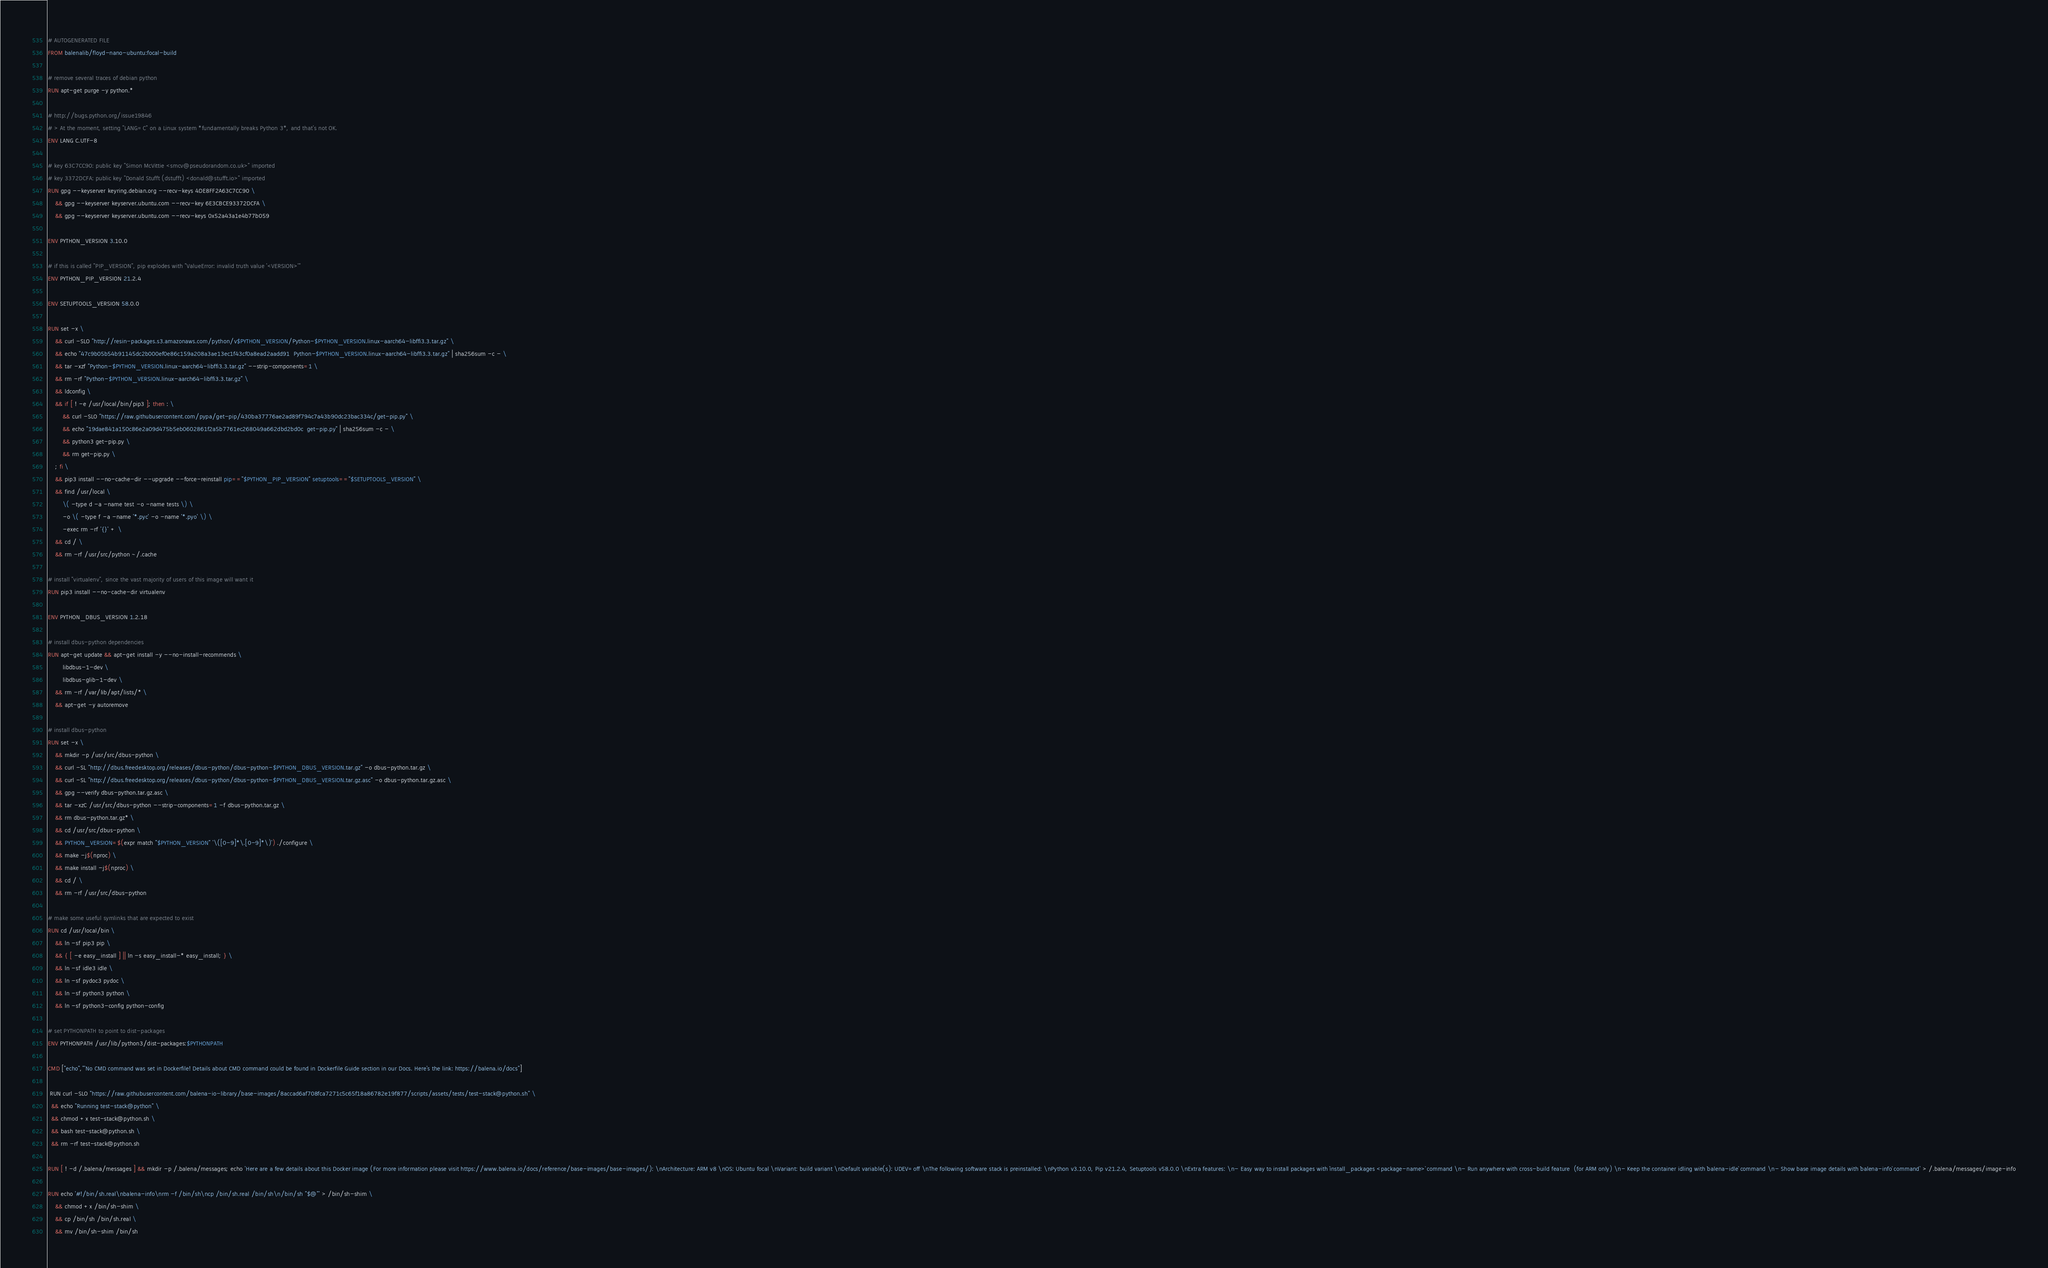<code> <loc_0><loc_0><loc_500><loc_500><_Dockerfile_># AUTOGENERATED FILE
FROM balenalib/floyd-nano-ubuntu:focal-build

# remove several traces of debian python
RUN apt-get purge -y python.*

# http://bugs.python.org/issue19846
# > At the moment, setting "LANG=C" on a Linux system *fundamentally breaks Python 3*, and that's not OK.
ENV LANG C.UTF-8

# key 63C7CC90: public key "Simon McVittie <smcv@pseudorandom.co.uk>" imported
# key 3372DCFA: public key "Donald Stufft (dstufft) <donald@stufft.io>" imported
RUN gpg --keyserver keyring.debian.org --recv-keys 4DE8FF2A63C7CC90 \
	&& gpg --keyserver keyserver.ubuntu.com --recv-key 6E3CBCE93372DCFA \
	&& gpg --keyserver keyserver.ubuntu.com --recv-keys 0x52a43a1e4b77b059

ENV PYTHON_VERSION 3.10.0

# if this is called "PIP_VERSION", pip explodes with "ValueError: invalid truth value '<VERSION>'"
ENV PYTHON_PIP_VERSION 21.2.4

ENV SETUPTOOLS_VERSION 58.0.0

RUN set -x \
	&& curl -SLO "http://resin-packages.s3.amazonaws.com/python/v$PYTHON_VERSION/Python-$PYTHON_VERSION.linux-aarch64-libffi3.3.tar.gz" \
	&& echo "47c9b05b54b91145dc2b000ef0e86c159a208a3ae13ec1f43cf0a8ead2aadd91  Python-$PYTHON_VERSION.linux-aarch64-libffi3.3.tar.gz" | sha256sum -c - \
	&& tar -xzf "Python-$PYTHON_VERSION.linux-aarch64-libffi3.3.tar.gz" --strip-components=1 \
	&& rm -rf "Python-$PYTHON_VERSION.linux-aarch64-libffi3.3.tar.gz" \
	&& ldconfig \
	&& if [ ! -e /usr/local/bin/pip3 ]; then : \
		&& curl -SLO "https://raw.githubusercontent.com/pypa/get-pip/430ba37776ae2ad89f794c7a43b90dc23bac334c/get-pip.py" \
		&& echo "19dae841a150c86e2a09d475b5eb0602861f2a5b7761ec268049a662dbd2bd0c  get-pip.py" | sha256sum -c - \
		&& python3 get-pip.py \
		&& rm get-pip.py \
	; fi \
	&& pip3 install --no-cache-dir --upgrade --force-reinstall pip=="$PYTHON_PIP_VERSION" setuptools=="$SETUPTOOLS_VERSION" \
	&& find /usr/local \
		\( -type d -a -name test -o -name tests \) \
		-o \( -type f -a -name '*.pyc' -o -name '*.pyo' \) \
		-exec rm -rf '{}' + \
	&& cd / \
	&& rm -rf /usr/src/python ~/.cache

# install "virtualenv", since the vast majority of users of this image will want it
RUN pip3 install --no-cache-dir virtualenv

ENV PYTHON_DBUS_VERSION 1.2.18

# install dbus-python dependencies 
RUN apt-get update && apt-get install -y --no-install-recommends \
		libdbus-1-dev \
		libdbus-glib-1-dev \
	&& rm -rf /var/lib/apt/lists/* \
	&& apt-get -y autoremove

# install dbus-python
RUN set -x \
	&& mkdir -p /usr/src/dbus-python \
	&& curl -SL "http://dbus.freedesktop.org/releases/dbus-python/dbus-python-$PYTHON_DBUS_VERSION.tar.gz" -o dbus-python.tar.gz \
	&& curl -SL "http://dbus.freedesktop.org/releases/dbus-python/dbus-python-$PYTHON_DBUS_VERSION.tar.gz.asc" -o dbus-python.tar.gz.asc \
	&& gpg --verify dbus-python.tar.gz.asc \
	&& tar -xzC /usr/src/dbus-python --strip-components=1 -f dbus-python.tar.gz \
	&& rm dbus-python.tar.gz* \
	&& cd /usr/src/dbus-python \
	&& PYTHON_VERSION=$(expr match "$PYTHON_VERSION" '\([0-9]*\.[0-9]*\)') ./configure \
	&& make -j$(nproc) \
	&& make install -j$(nproc) \
	&& cd / \
	&& rm -rf /usr/src/dbus-python

# make some useful symlinks that are expected to exist
RUN cd /usr/local/bin \
	&& ln -sf pip3 pip \
	&& { [ -e easy_install ] || ln -s easy_install-* easy_install; } \
	&& ln -sf idle3 idle \
	&& ln -sf pydoc3 pydoc \
	&& ln -sf python3 python \
	&& ln -sf python3-config python-config

# set PYTHONPATH to point to dist-packages
ENV PYTHONPATH /usr/lib/python3/dist-packages:$PYTHONPATH

CMD ["echo","'No CMD command was set in Dockerfile! Details about CMD command could be found in Dockerfile Guide section in our Docs. Here's the link: https://balena.io/docs"]

 RUN curl -SLO "https://raw.githubusercontent.com/balena-io-library/base-images/8accad6af708fca7271c5c65f18a86782e19f877/scripts/assets/tests/test-stack@python.sh" \
  && echo "Running test-stack@python" \
  && chmod +x test-stack@python.sh \
  && bash test-stack@python.sh \
  && rm -rf test-stack@python.sh 

RUN [ ! -d /.balena/messages ] && mkdir -p /.balena/messages; echo 'Here are a few details about this Docker image (For more information please visit https://www.balena.io/docs/reference/base-images/base-images/): \nArchitecture: ARM v8 \nOS: Ubuntu focal \nVariant: build variant \nDefault variable(s): UDEV=off \nThe following software stack is preinstalled: \nPython v3.10.0, Pip v21.2.4, Setuptools v58.0.0 \nExtra features: \n- Easy way to install packages with `install_packages <package-name>` command \n- Run anywhere with cross-build feature  (for ARM only) \n- Keep the container idling with `balena-idle` command \n- Show base image details with `balena-info` command' > /.balena/messages/image-info

RUN echo '#!/bin/sh.real\nbalena-info\nrm -f /bin/sh\ncp /bin/sh.real /bin/sh\n/bin/sh "$@"' > /bin/sh-shim \
	&& chmod +x /bin/sh-shim \
	&& cp /bin/sh /bin/sh.real \
	&& mv /bin/sh-shim /bin/sh</code> 